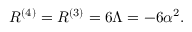<formula> <loc_0><loc_0><loc_500><loc_500>R ^ { ( 4 ) } = R ^ { ( 3 ) } = 6 \Lambda = - 6 \alpha ^ { 2 } .</formula> 